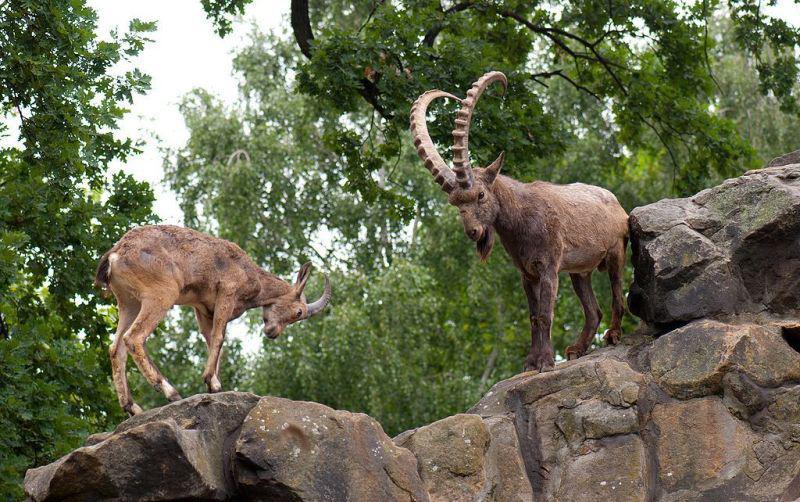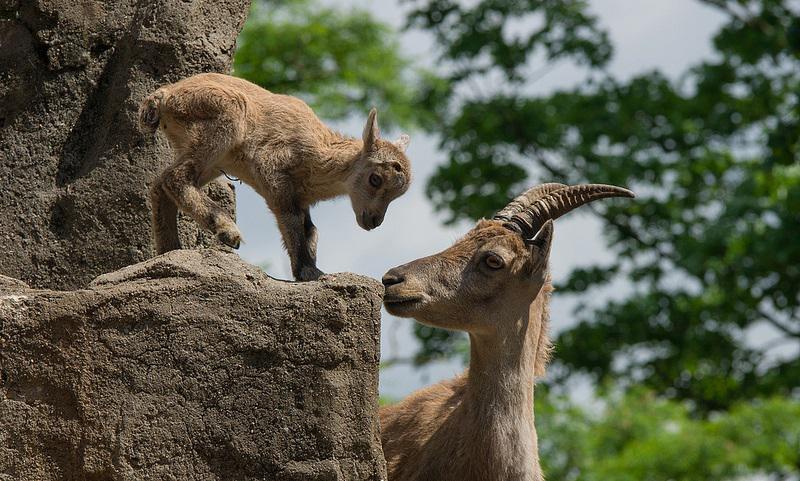The first image is the image on the left, the second image is the image on the right. For the images displayed, is the sentence "The left image shows at least one goat with very long horns on its head." factually correct? Answer yes or no. Yes. The first image is the image on the left, the second image is the image on the right. For the images displayed, is the sentence "Four or fewer goats are visible." factually correct? Answer yes or no. Yes. 